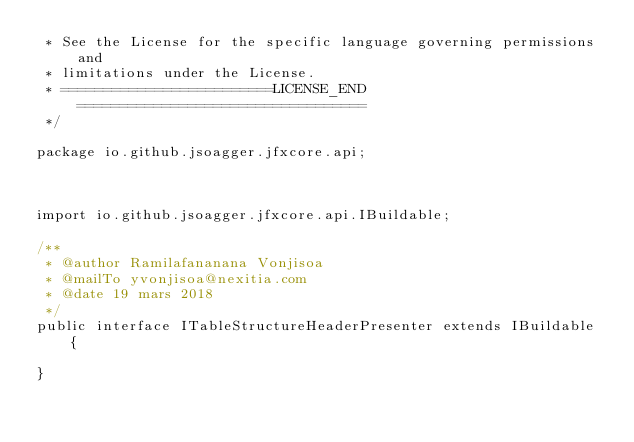Convert code to text. <code><loc_0><loc_0><loc_500><loc_500><_Java_> * See the License for the specific language governing permissions and
 * limitations under the License.
 * =========================LICENSE_END==================================
 */

package io.github.jsoagger.jfxcore.api;



import io.github.jsoagger.jfxcore.api.IBuildable;

/**
 * @author Ramilafananana Vonjisoa
 * @mailTo yvonjisoa@nexitia.com
 * @date 19 mars 2018
 */
public interface ITableStructureHeaderPresenter extends IBuildable {

}
</code> 